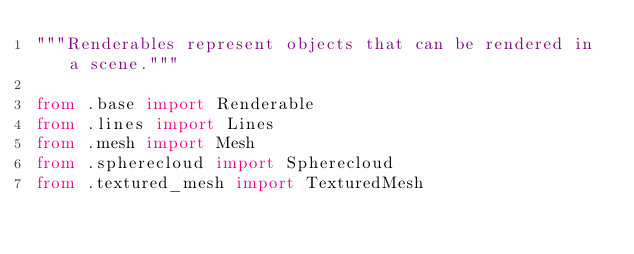<code> <loc_0><loc_0><loc_500><loc_500><_Python_>"""Renderables represent objects that can be rendered in a scene."""

from .base import Renderable
from .lines import Lines
from .mesh import Mesh
from .spherecloud import Spherecloud
from .textured_mesh import TexturedMesh
</code> 